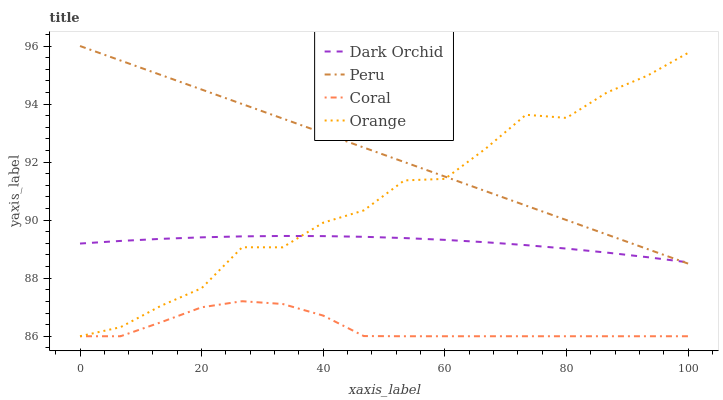Does Coral have the minimum area under the curve?
Answer yes or no. Yes. Does Peru have the maximum area under the curve?
Answer yes or no. Yes. Does Peru have the minimum area under the curve?
Answer yes or no. No. Does Coral have the maximum area under the curve?
Answer yes or no. No. Is Peru the smoothest?
Answer yes or no. Yes. Is Orange the roughest?
Answer yes or no. Yes. Is Coral the smoothest?
Answer yes or no. No. Is Coral the roughest?
Answer yes or no. No. Does Orange have the lowest value?
Answer yes or no. Yes. Does Peru have the lowest value?
Answer yes or no. No. Does Peru have the highest value?
Answer yes or no. Yes. Does Coral have the highest value?
Answer yes or no. No. Is Coral less than Peru?
Answer yes or no. Yes. Is Peru greater than Coral?
Answer yes or no. Yes. Does Dark Orchid intersect Orange?
Answer yes or no. Yes. Is Dark Orchid less than Orange?
Answer yes or no. No. Is Dark Orchid greater than Orange?
Answer yes or no. No. Does Coral intersect Peru?
Answer yes or no. No. 